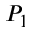<formula> <loc_0><loc_0><loc_500><loc_500>P _ { 1 }</formula> 